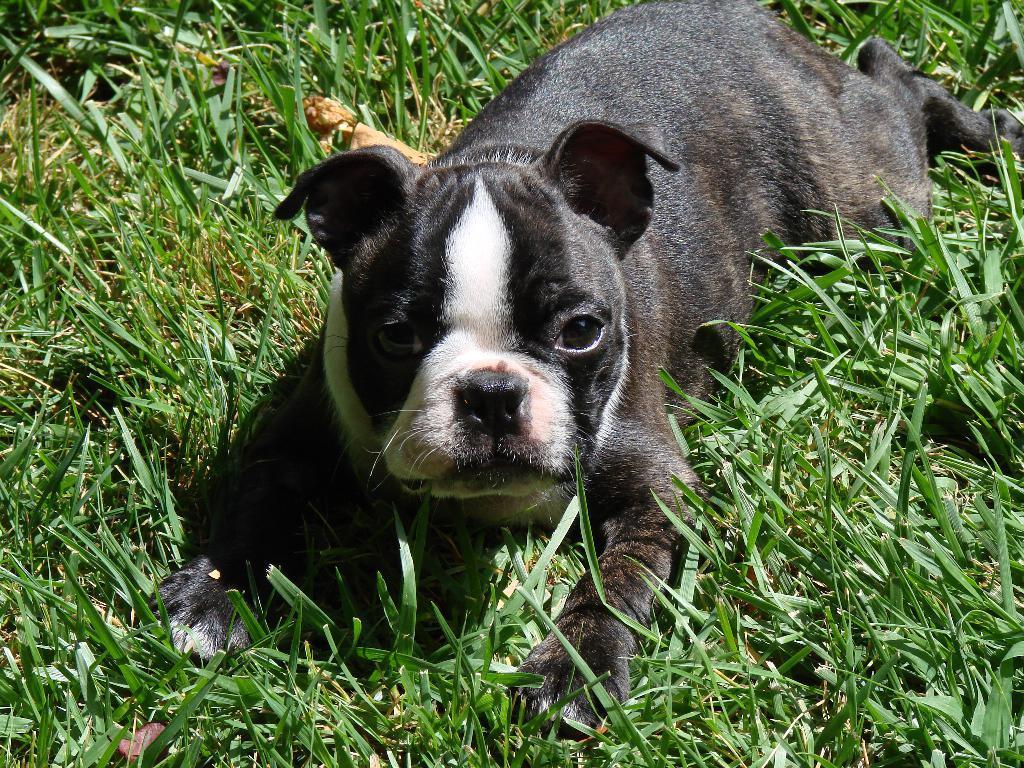Could you give a brief overview of what you see in this image? In this image I can see a dog which is black, brown and white in color and some grass on the ground. 